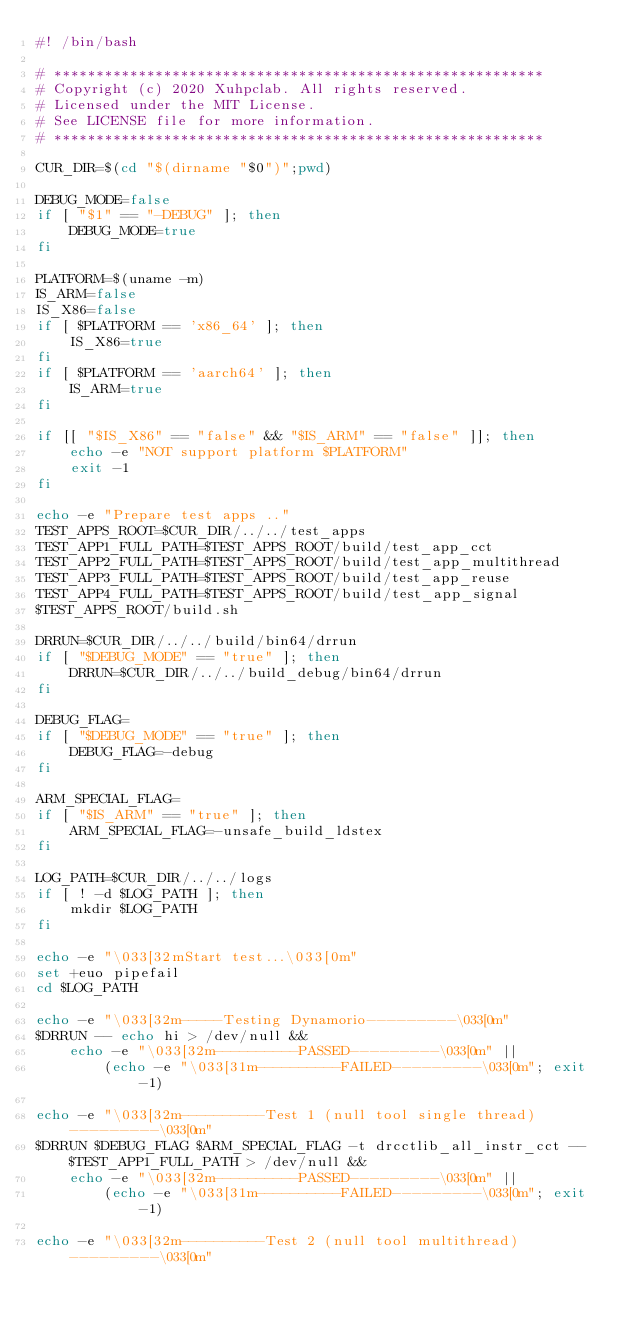<code> <loc_0><loc_0><loc_500><loc_500><_Bash_>#! /bin/bash

# **********************************************************
# Copyright (c) 2020 Xuhpclab. All rights reserved.
# Licensed under the MIT License.
# See LICENSE file for more information.
# **********************************************************

CUR_DIR=$(cd "$(dirname "$0")";pwd)

DEBUG_MODE=false
if [ "$1" == "-DEBUG" ]; then
    DEBUG_MODE=true
fi

PLATFORM=$(uname -m)
IS_ARM=false
IS_X86=false
if [ $PLATFORM == 'x86_64' ]; then
    IS_X86=true
fi
if [ $PLATFORM == 'aarch64' ]; then
    IS_ARM=true
fi

if [[ "$IS_X86" == "false" && "$IS_ARM" == "false" ]]; then
    echo -e "NOT support platform $PLATFORM"
    exit -1
fi

echo -e "Prepare test apps .."
TEST_APPS_ROOT=$CUR_DIR/../../test_apps
TEST_APP1_FULL_PATH=$TEST_APPS_ROOT/build/test_app_cct
TEST_APP2_FULL_PATH=$TEST_APPS_ROOT/build/test_app_multithread
TEST_APP3_FULL_PATH=$TEST_APPS_ROOT/build/test_app_reuse
TEST_APP4_FULL_PATH=$TEST_APPS_ROOT/build/test_app_signal
$TEST_APPS_ROOT/build.sh

DRRUN=$CUR_DIR/../../build/bin64/drrun
if [ "$DEBUG_MODE" == "true" ]; then
    DRRUN=$CUR_DIR/../../build_debug/bin64/drrun
fi

DEBUG_FLAG=
if [ "$DEBUG_MODE" == "true" ]; then
    DEBUG_FLAG=-debug
fi

ARM_SPECIAL_FLAG=
if [ "$IS_ARM" == "true" ]; then
    ARM_SPECIAL_FLAG=-unsafe_build_ldstex
fi

LOG_PATH=$CUR_DIR/../../logs
if [ ! -d $LOG_PATH ]; then
    mkdir $LOG_PATH
fi

echo -e "\033[32mStart test...\033[0m"
set +euo pipefail
cd $LOG_PATH

echo -e "\033[32m-----Testing Dynamorio---------\033[0m"
$DRRUN -- echo hi > /dev/null &&
    echo -e "\033[32m----------PASSED---------\033[0m" ||
        (echo -e "\033[31m----------FAILED---------\033[0m"; exit -1)

echo -e "\033[32m----------Test 1 (null tool single thread)---------\033[0m"
$DRRUN $DEBUG_FLAG $ARM_SPECIAL_FLAG -t drcctlib_all_instr_cct -- $TEST_APP1_FULL_PATH > /dev/null &&
    echo -e "\033[32m----------PASSED---------\033[0m" ||
        (echo -e "\033[31m----------FAILED---------\033[0m"; exit -1)

echo -e "\033[32m----------Test 2 (null tool multithread)---------\033[0m"</code> 